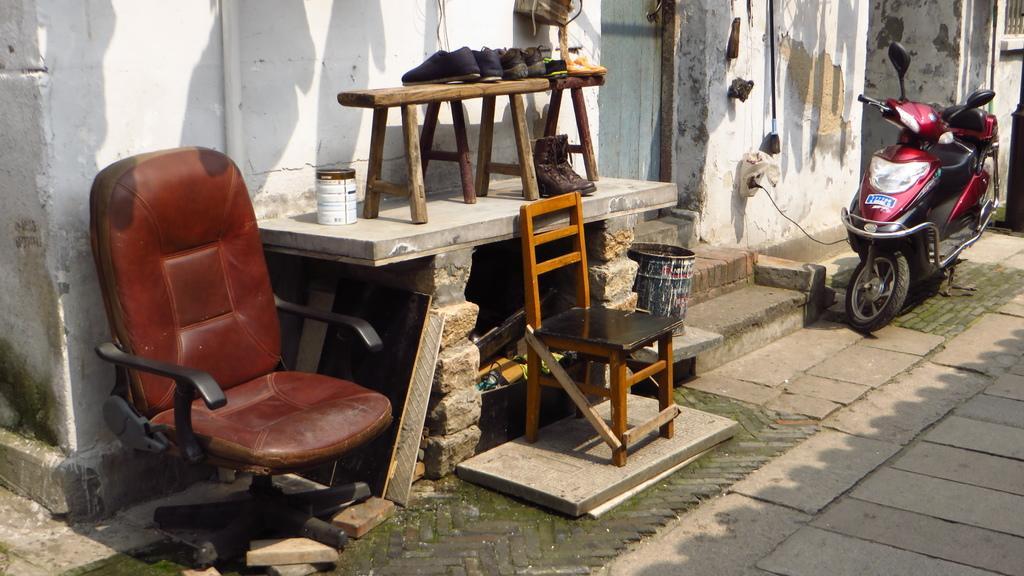Could you give a brief overview of what you see in this image? In this image we can see a brown color chair. There are few pairs of shoes, wooden chair, bucket and a table. On the background of the image we can see a maroon color scooter. This is the wall. 